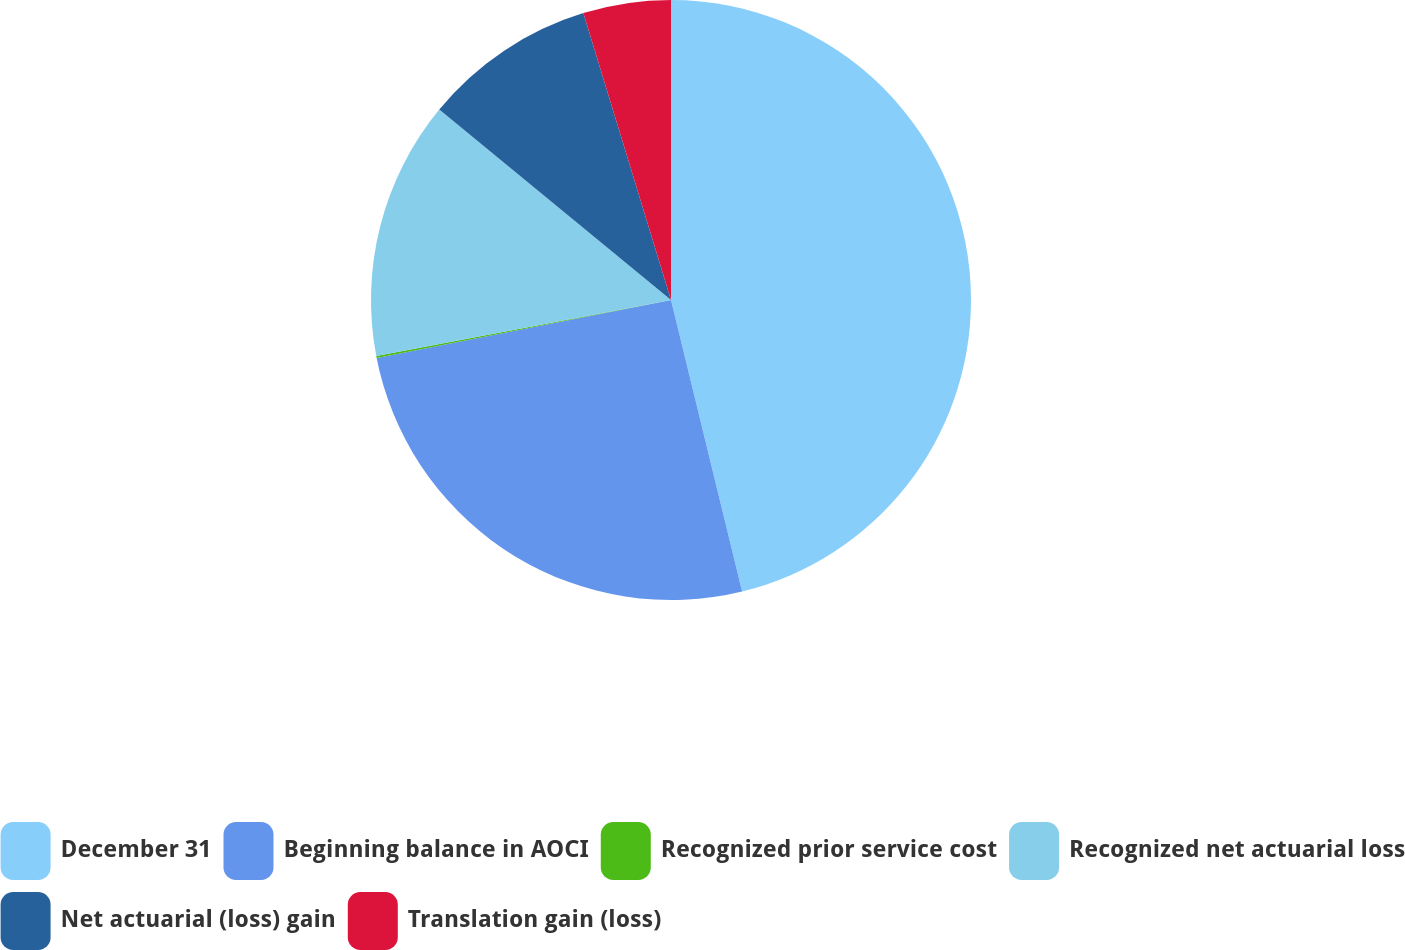Convert chart to OTSL. <chart><loc_0><loc_0><loc_500><loc_500><pie_chart><fcel>December 31<fcel>Beginning balance in AOCI<fcel>Recognized prior service cost<fcel>Recognized net actuarial loss<fcel>Net actuarial (loss) gain<fcel>Translation gain (loss)<nl><fcel>46.19%<fcel>25.71%<fcel>0.11%<fcel>13.94%<fcel>9.33%<fcel>4.72%<nl></chart> 